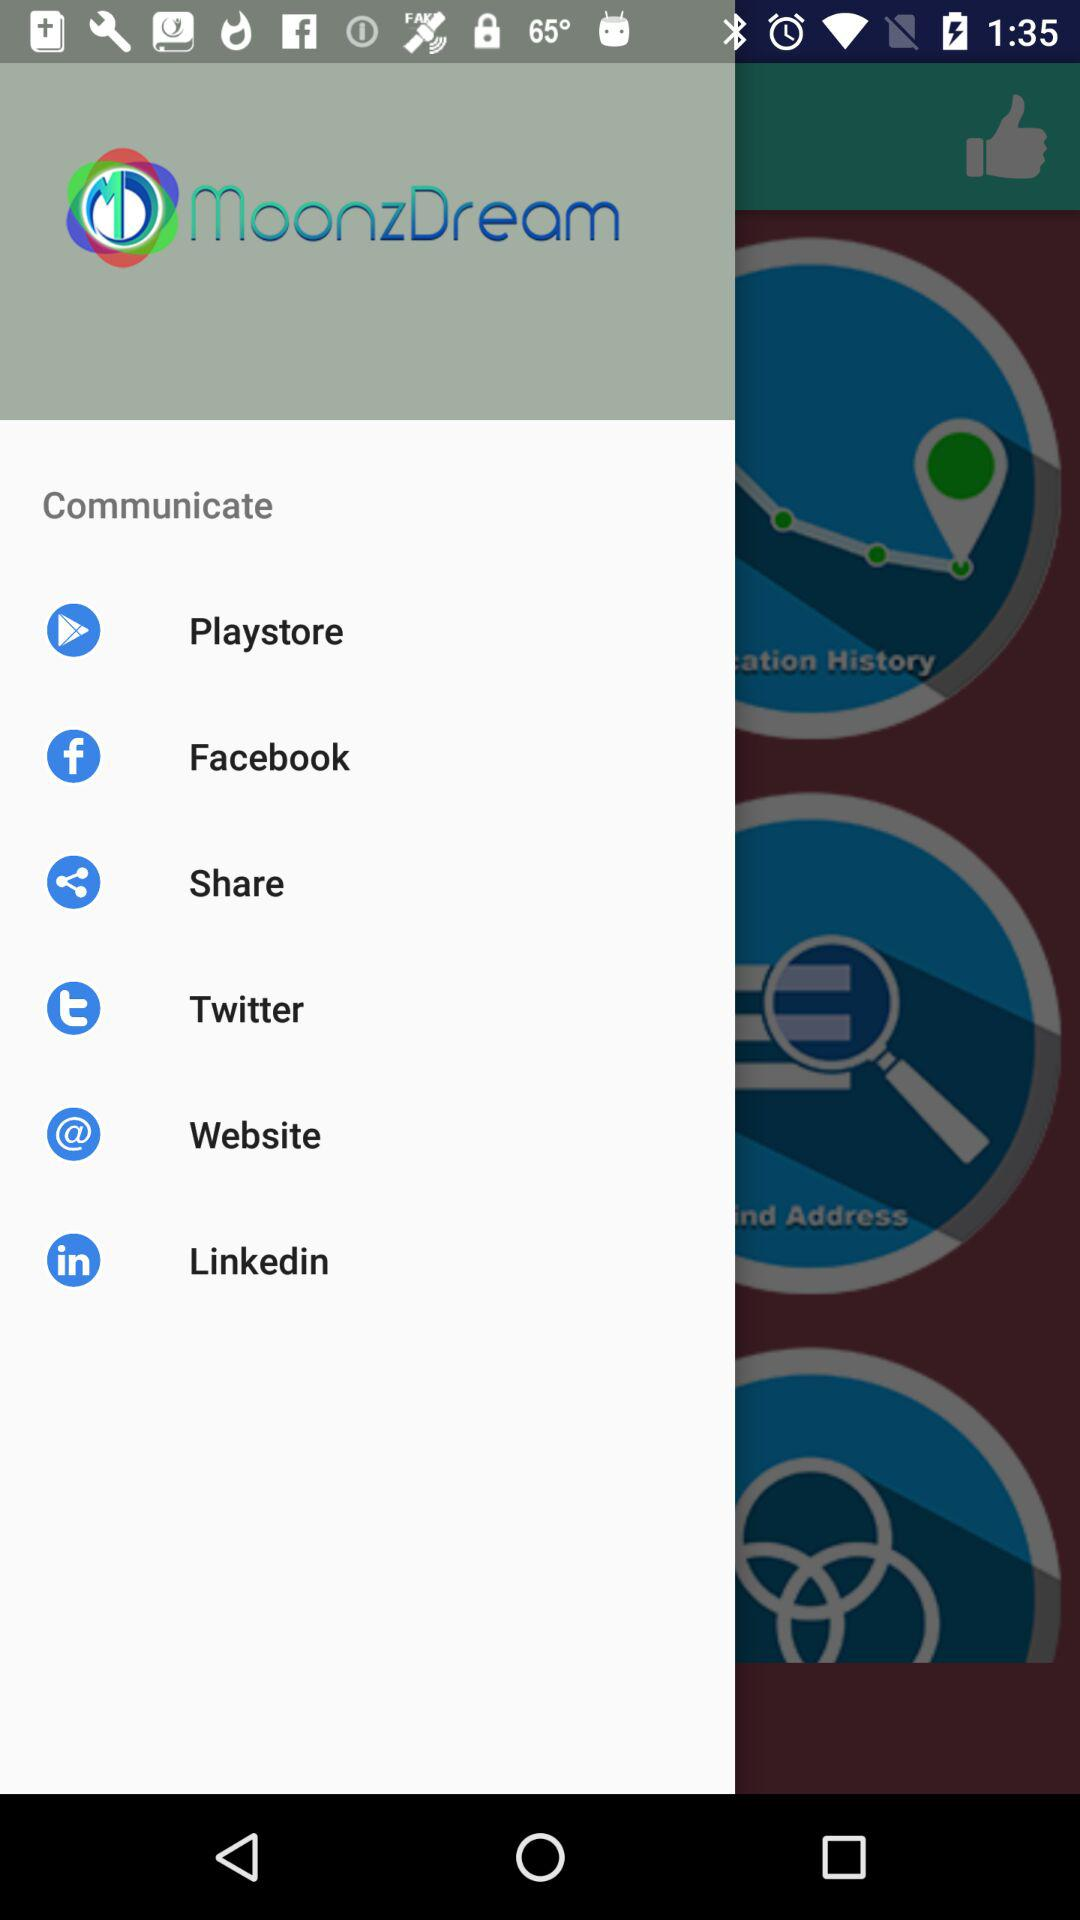What is the app name? The app name is "MoonzDream". 